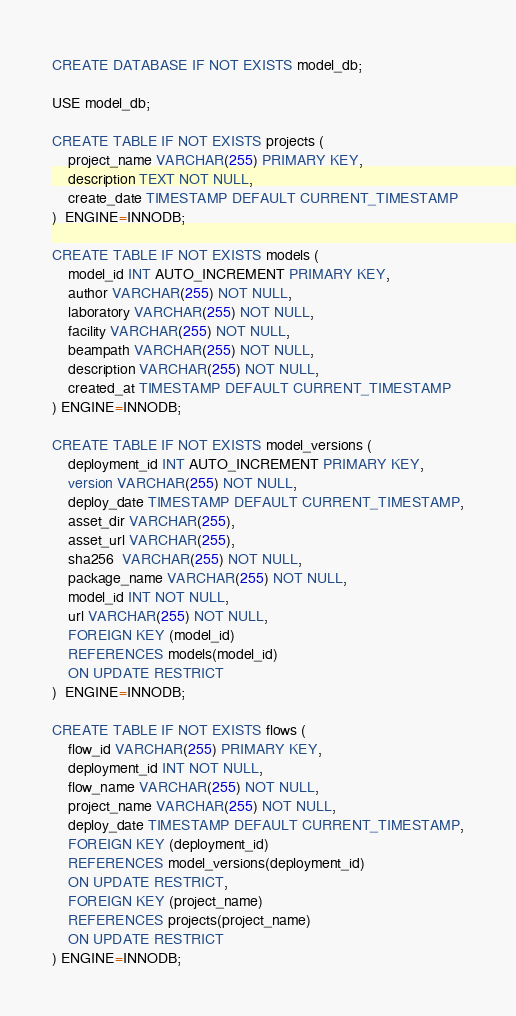<code> <loc_0><loc_0><loc_500><loc_500><_SQL_>CREATE DATABASE IF NOT EXISTS model_db;

USE model_db;

CREATE TABLE IF NOT EXISTS projects (
    project_name VARCHAR(255) PRIMARY KEY,
    description TEXT NOT NULL,
    create_date TIMESTAMP DEFAULT CURRENT_TIMESTAMP
)  ENGINE=INNODB;

CREATE TABLE IF NOT EXISTS models (
    model_id INT AUTO_INCREMENT PRIMARY KEY,
    author VARCHAR(255) NOT NULL,
    laboratory VARCHAR(255) NOT NULL,
    facility VARCHAR(255) NOT NULL,
    beampath VARCHAR(255) NOT NULL,
    description VARCHAR(255) NOT NULL,
    created_at TIMESTAMP DEFAULT CURRENT_TIMESTAMP
) ENGINE=INNODB;

CREATE TABLE IF NOT EXISTS model_versions (
    deployment_id INT AUTO_INCREMENT PRIMARY KEY,
    version VARCHAR(255) NOT NULL,
    deploy_date TIMESTAMP DEFAULT CURRENT_TIMESTAMP,
    asset_dir VARCHAR(255),
    asset_url VARCHAR(255),
    sha256  VARCHAR(255) NOT NULL,
    package_name VARCHAR(255) NOT NULL,
    model_id INT NOT NULL,
    url VARCHAR(255) NOT NULL,
    FOREIGN KEY (model_id)
    REFERENCES models(model_id)
    ON UPDATE RESTRICT
)  ENGINE=INNODB;

CREATE TABLE IF NOT EXISTS flows (
    flow_id VARCHAR(255) PRIMARY KEY,
    deployment_id INT NOT NULL,
    flow_name VARCHAR(255) NOT NULL,
    project_name VARCHAR(255) NOT NULL,
    deploy_date TIMESTAMP DEFAULT CURRENT_TIMESTAMP,
    FOREIGN KEY (deployment_id)
    REFERENCES model_versions(deployment_id)
    ON UPDATE RESTRICT,
    FOREIGN KEY (project_name)
    REFERENCES projects(project_name)
    ON UPDATE RESTRICT
) ENGINE=INNODB;</code> 